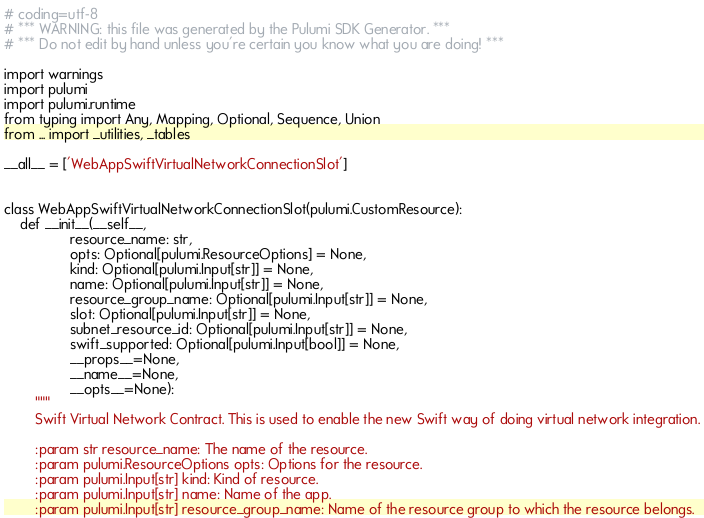Convert code to text. <code><loc_0><loc_0><loc_500><loc_500><_Python_># coding=utf-8
# *** WARNING: this file was generated by the Pulumi SDK Generator. ***
# *** Do not edit by hand unless you're certain you know what you are doing! ***

import warnings
import pulumi
import pulumi.runtime
from typing import Any, Mapping, Optional, Sequence, Union
from ... import _utilities, _tables

__all__ = ['WebAppSwiftVirtualNetworkConnectionSlot']


class WebAppSwiftVirtualNetworkConnectionSlot(pulumi.CustomResource):
    def __init__(__self__,
                 resource_name: str,
                 opts: Optional[pulumi.ResourceOptions] = None,
                 kind: Optional[pulumi.Input[str]] = None,
                 name: Optional[pulumi.Input[str]] = None,
                 resource_group_name: Optional[pulumi.Input[str]] = None,
                 slot: Optional[pulumi.Input[str]] = None,
                 subnet_resource_id: Optional[pulumi.Input[str]] = None,
                 swift_supported: Optional[pulumi.Input[bool]] = None,
                 __props__=None,
                 __name__=None,
                 __opts__=None):
        """
        Swift Virtual Network Contract. This is used to enable the new Swift way of doing virtual network integration.

        :param str resource_name: The name of the resource.
        :param pulumi.ResourceOptions opts: Options for the resource.
        :param pulumi.Input[str] kind: Kind of resource.
        :param pulumi.Input[str] name: Name of the app.
        :param pulumi.Input[str] resource_group_name: Name of the resource group to which the resource belongs.</code> 